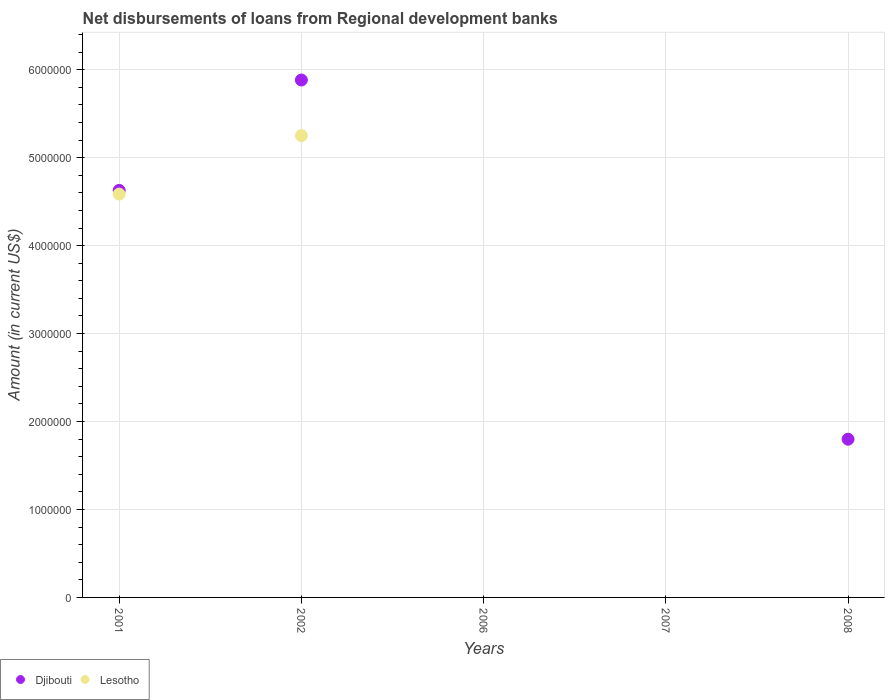How many different coloured dotlines are there?
Ensure brevity in your answer.  2. Is the number of dotlines equal to the number of legend labels?
Offer a terse response. No. What is the amount of disbursements of loans from regional development banks in Djibouti in 2002?
Provide a succinct answer. 5.88e+06. Across all years, what is the maximum amount of disbursements of loans from regional development banks in Djibouti?
Offer a very short reply. 5.88e+06. Across all years, what is the minimum amount of disbursements of loans from regional development banks in Djibouti?
Make the answer very short. 0. In which year was the amount of disbursements of loans from regional development banks in Djibouti maximum?
Offer a terse response. 2002. What is the total amount of disbursements of loans from regional development banks in Djibouti in the graph?
Provide a short and direct response. 1.23e+07. What is the difference between the amount of disbursements of loans from regional development banks in Djibouti in 2001 and that in 2008?
Your answer should be very brief. 2.83e+06. What is the difference between the amount of disbursements of loans from regional development banks in Lesotho in 2006 and the amount of disbursements of loans from regional development banks in Djibouti in 2001?
Your response must be concise. -4.63e+06. What is the average amount of disbursements of loans from regional development banks in Lesotho per year?
Provide a short and direct response. 1.97e+06. In the year 2002, what is the difference between the amount of disbursements of loans from regional development banks in Lesotho and amount of disbursements of loans from regional development banks in Djibouti?
Provide a short and direct response. -6.32e+05. In how many years, is the amount of disbursements of loans from regional development banks in Djibouti greater than 2200000 US$?
Provide a succinct answer. 2. What is the ratio of the amount of disbursements of loans from regional development banks in Lesotho in 2001 to that in 2002?
Ensure brevity in your answer.  0.87. What is the difference between the highest and the second highest amount of disbursements of loans from regional development banks in Djibouti?
Ensure brevity in your answer.  1.26e+06. What is the difference between the highest and the lowest amount of disbursements of loans from regional development banks in Djibouti?
Offer a very short reply. 5.88e+06. Does the amount of disbursements of loans from regional development banks in Djibouti monotonically increase over the years?
Your answer should be very brief. No. Is the amount of disbursements of loans from regional development banks in Djibouti strictly less than the amount of disbursements of loans from regional development banks in Lesotho over the years?
Offer a very short reply. No. How many years are there in the graph?
Make the answer very short. 5. What is the difference between two consecutive major ticks on the Y-axis?
Your answer should be compact. 1.00e+06. Are the values on the major ticks of Y-axis written in scientific E-notation?
Provide a succinct answer. No. Where does the legend appear in the graph?
Offer a terse response. Bottom left. What is the title of the graph?
Provide a short and direct response. Net disbursements of loans from Regional development banks. Does "Bahamas" appear as one of the legend labels in the graph?
Make the answer very short. No. What is the label or title of the Y-axis?
Offer a very short reply. Amount (in current US$). What is the Amount (in current US$) in Djibouti in 2001?
Your answer should be compact. 4.63e+06. What is the Amount (in current US$) in Lesotho in 2001?
Make the answer very short. 4.59e+06. What is the Amount (in current US$) in Djibouti in 2002?
Ensure brevity in your answer.  5.88e+06. What is the Amount (in current US$) in Lesotho in 2002?
Offer a very short reply. 5.25e+06. What is the Amount (in current US$) in Djibouti in 2006?
Give a very brief answer. 0. What is the Amount (in current US$) in Djibouti in 2007?
Provide a succinct answer. 0. What is the Amount (in current US$) of Lesotho in 2007?
Make the answer very short. 0. What is the Amount (in current US$) in Djibouti in 2008?
Your response must be concise. 1.80e+06. Across all years, what is the maximum Amount (in current US$) of Djibouti?
Make the answer very short. 5.88e+06. Across all years, what is the maximum Amount (in current US$) of Lesotho?
Give a very brief answer. 5.25e+06. Across all years, what is the minimum Amount (in current US$) in Djibouti?
Your answer should be compact. 0. What is the total Amount (in current US$) in Djibouti in the graph?
Your answer should be compact. 1.23e+07. What is the total Amount (in current US$) of Lesotho in the graph?
Ensure brevity in your answer.  9.84e+06. What is the difference between the Amount (in current US$) in Djibouti in 2001 and that in 2002?
Give a very brief answer. -1.26e+06. What is the difference between the Amount (in current US$) of Lesotho in 2001 and that in 2002?
Your response must be concise. -6.65e+05. What is the difference between the Amount (in current US$) of Djibouti in 2001 and that in 2008?
Provide a short and direct response. 2.83e+06. What is the difference between the Amount (in current US$) in Djibouti in 2002 and that in 2008?
Offer a terse response. 4.08e+06. What is the difference between the Amount (in current US$) of Djibouti in 2001 and the Amount (in current US$) of Lesotho in 2002?
Give a very brief answer. -6.23e+05. What is the average Amount (in current US$) of Djibouti per year?
Your response must be concise. 2.46e+06. What is the average Amount (in current US$) of Lesotho per year?
Ensure brevity in your answer.  1.97e+06. In the year 2001, what is the difference between the Amount (in current US$) in Djibouti and Amount (in current US$) in Lesotho?
Your response must be concise. 4.20e+04. In the year 2002, what is the difference between the Amount (in current US$) in Djibouti and Amount (in current US$) in Lesotho?
Your answer should be very brief. 6.32e+05. What is the ratio of the Amount (in current US$) in Djibouti in 2001 to that in 2002?
Make the answer very short. 0.79. What is the ratio of the Amount (in current US$) of Lesotho in 2001 to that in 2002?
Offer a terse response. 0.87. What is the ratio of the Amount (in current US$) of Djibouti in 2001 to that in 2008?
Offer a very short reply. 2.57. What is the ratio of the Amount (in current US$) in Djibouti in 2002 to that in 2008?
Ensure brevity in your answer.  3.27. What is the difference between the highest and the second highest Amount (in current US$) in Djibouti?
Provide a succinct answer. 1.26e+06. What is the difference between the highest and the lowest Amount (in current US$) of Djibouti?
Make the answer very short. 5.88e+06. What is the difference between the highest and the lowest Amount (in current US$) of Lesotho?
Ensure brevity in your answer.  5.25e+06. 